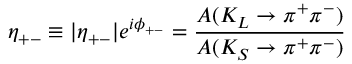<formula> <loc_0><loc_0><loc_500><loc_500>\eta _ { + - } \equiv | \eta _ { + - } | e ^ { i \phi _ { + - } } = \frac { A ( K _ { L } \rightarrow \pi ^ { + } \pi ^ { - } ) } { A ( K _ { S } \rightarrow \pi ^ { + } \pi ^ { - } ) }</formula> 